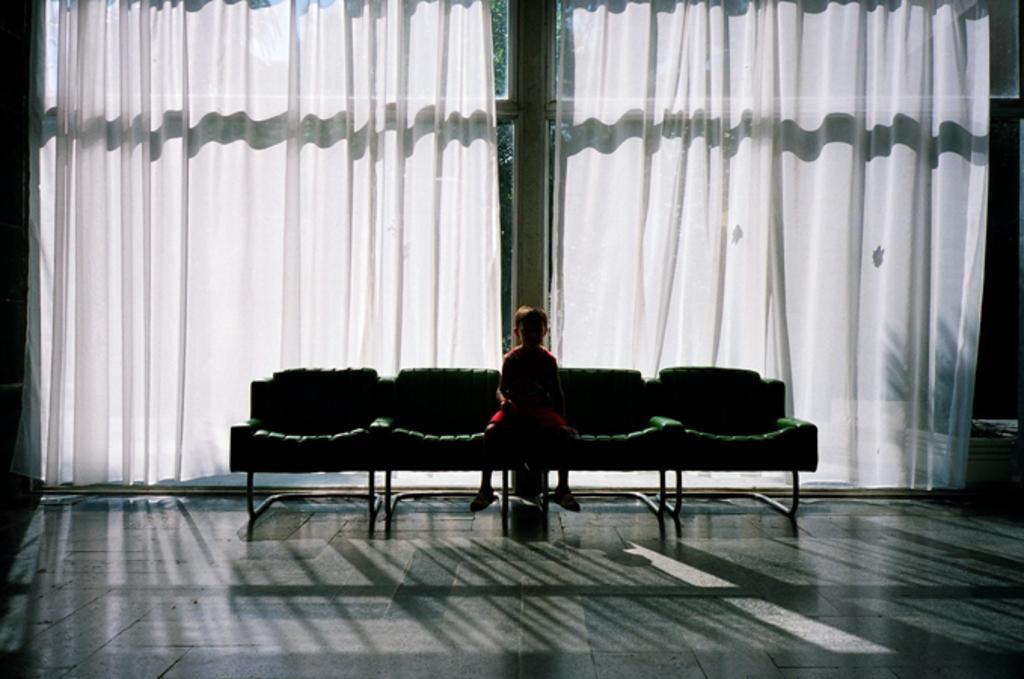Can you describe this image briefly? In the picture we can see a floor on it, we can see four chairs on it, we can see a boy sitting and behind we can see a glass wall with two white curtains. 